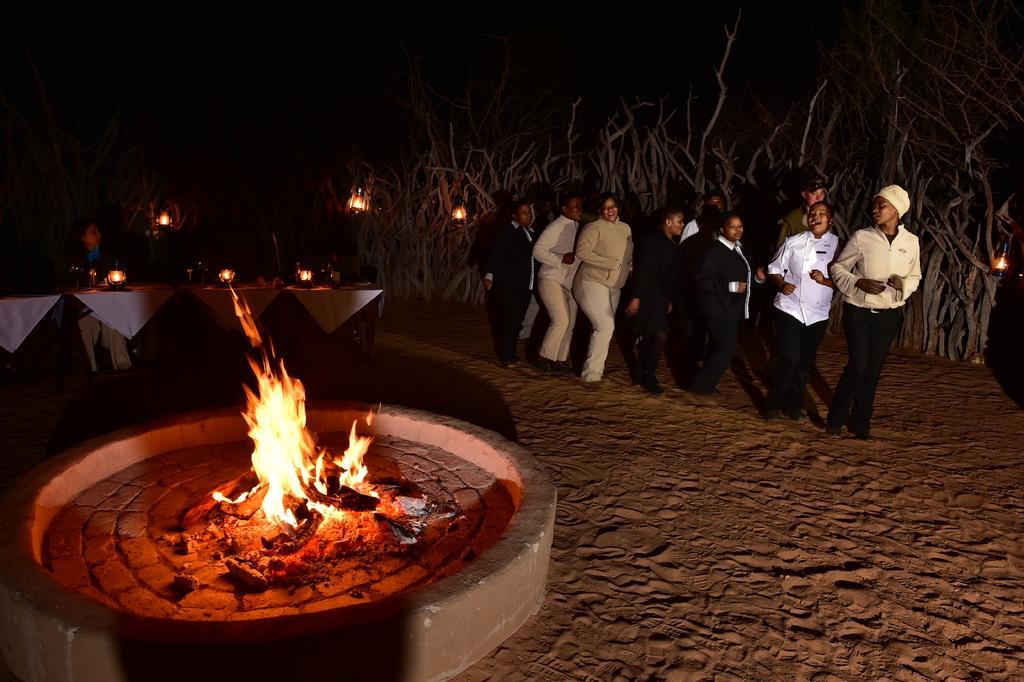Describe this image in one or two sentences. Here people are standing in the sand, here there are trees and a fire. 